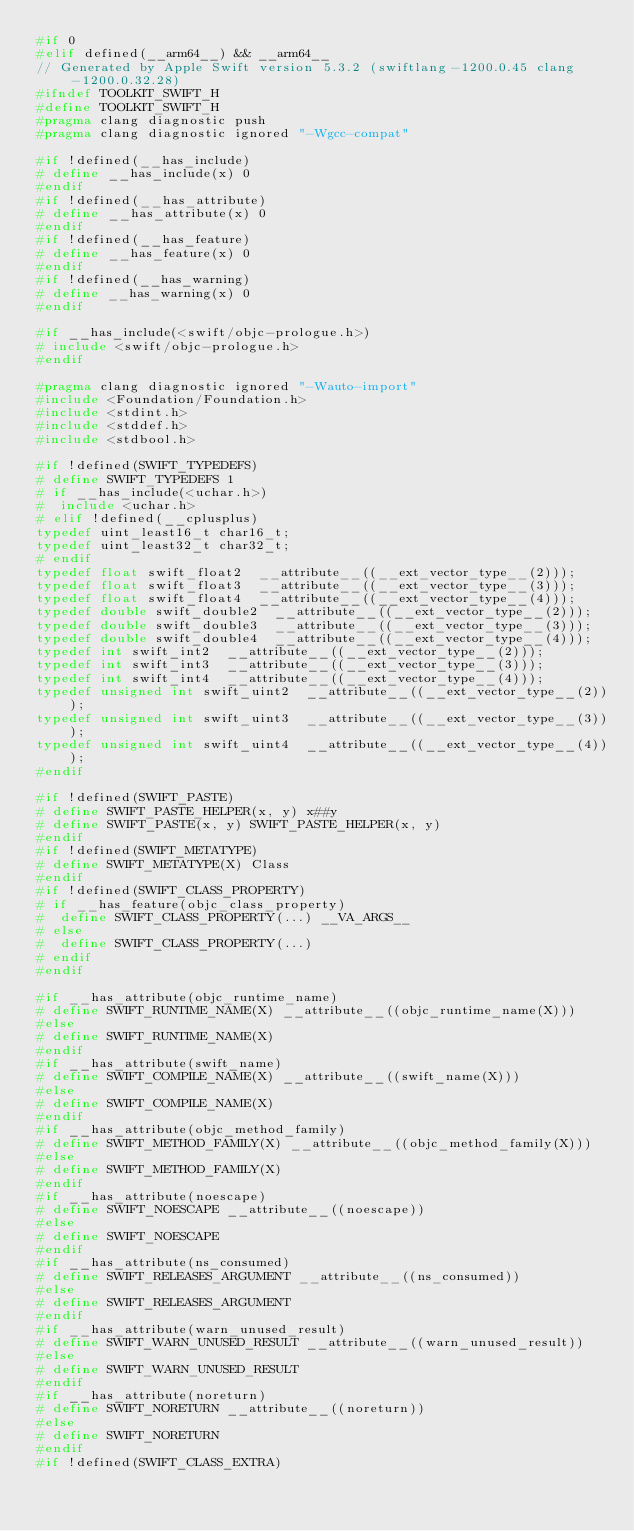<code> <loc_0><loc_0><loc_500><loc_500><_C_>#if 0
#elif defined(__arm64__) && __arm64__
// Generated by Apple Swift version 5.3.2 (swiftlang-1200.0.45 clang-1200.0.32.28)
#ifndef TOOLKIT_SWIFT_H
#define TOOLKIT_SWIFT_H
#pragma clang diagnostic push
#pragma clang diagnostic ignored "-Wgcc-compat"

#if !defined(__has_include)
# define __has_include(x) 0
#endif
#if !defined(__has_attribute)
# define __has_attribute(x) 0
#endif
#if !defined(__has_feature)
# define __has_feature(x) 0
#endif
#if !defined(__has_warning)
# define __has_warning(x) 0
#endif

#if __has_include(<swift/objc-prologue.h>)
# include <swift/objc-prologue.h>
#endif

#pragma clang diagnostic ignored "-Wauto-import"
#include <Foundation/Foundation.h>
#include <stdint.h>
#include <stddef.h>
#include <stdbool.h>

#if !defined(SWIFT_TYPEDEFS)
# define SWIFT_TYPEDEFS 1
# if __has_include(<uchar.h>)
#  include <uchar.h>
# elif !defined(__cplusplus)
typedef uint_least16_t char16_t;
typedef uint_least32_t char32_t;
# endif
typedef float swift_float2  __attribute__((__ext_vector_type__(2)));
typedef float swift_float3  __attribute__((__ext_vector_type__(3)));
typedef float swift_float4  __attribute__((__ext_vector_type__(4)));
typedef double swift_double2  __attribute__((__ext_vector_type__(2)));
typedef double swift_double3  __attribute__((__ext_vector_type__(3)));
typedef double swift_double4  __attribute__((__ext_vector_type__(4)));
typedef int swift_int2  __attribute__((__ext_vector_type__(2)));
typedef int swift_int3  __attribute__((__ext_vector_type__(3)));
typedef int swift_int4  __attribute__((__ext_vector_type__(4)));
typedef unsigned int swift_uint2  __attribute__((__ext_vector_type__(2)));
typedef unsigned int swift_uint3  __attribute__((__ext_vector_type__(3)));
typedef unsigned int swift_uint4  __attribute__((__ext_vector_type__(4)));
#endif

#if !defined(SWIFT_PASTE)
# define SWIFT_PASTE_HELPER(x, y) x##y
# define SWIFT_PASTE(x, y) SWIFT_PASTE_HELPER(x, y)
#endif
#if !defined(SWIFT_METATYPE)
# define SWIFT_METATYPE(X) Class
#endif
#if !defined(SWIFT_CLASS_PROPERTY)
# if __has_feature(objc_class_property)
#  define SWIFT_CLASS_PROPERTY(...) __VA_ARGS__
# else
#  define SWIFT_CLASS_PROPERTY(...)
# endif
#endif

#if __has_attribute(objc_runtime_name)
# define SWIFT_RUNTIME_NAME(X) __attribute__((objc_runtime_name(X)))
#else
# define SWIFT_RUNTIME_NAME(X)
#endif
#if __has_attribute(swift_name)
# define SWIFT_COMPILE_NAME(X) __attribute__((swift_name(X)))
#else
# define SWIFT_COMPILE_NAME(X)
#endif
#if __has_attribute(objc_method_family)
# define SWIFT_METHOD_FAMILY(X) __attribute__((objc_method_family(X)))
#else
# define SWIFT_METHOD_FAMILY(X)
#endif
#if __has_attribute(noescape)
# define SWIFT_NOESCAPE __attribute__((noescape))
#else
# define SWIFT_NOESCAPE
#endif
#if __has_attribute(ns_consumed)
# define SWIFT_RELEASES_ARGUMENT __attribute__((ns_consumed))
#else
# define SWIFT_RELEASES_ARGUMENT
#endif
#if __has_attribute(warn_unused_result)
# define SWIFT_WARN_UNUSED_RESULT __attribute__((warn_unused_result))
#else
# define SWIFT_WARN_UNUSED_RESULT
#endif
#if __has_attribute(noreturn)
# define SWIFT_NORETURN __attribute__((noreturn))
#else
# define SWIFT_NORETURN
#endif
#if !defined(SWIFT_CLASS_EXTRA)</code> 